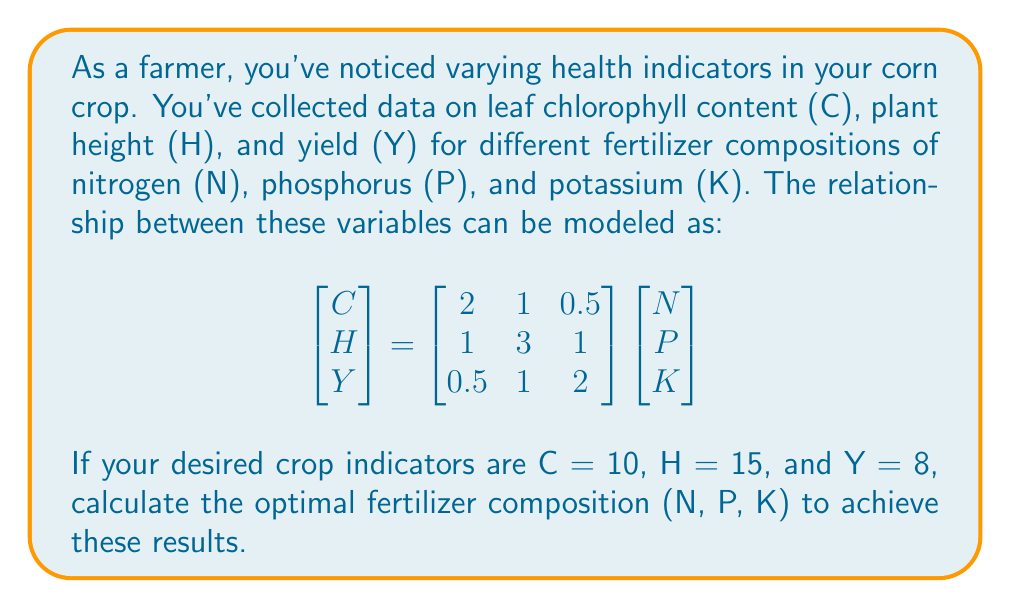Can you solve this math problem? To solve this inverse problem, we need to find the values of N, P, and K that satisfy the given equation with the desired crop indicators. Let's approach this step-by-step:

1) We have the equation:
   $$\begin{bmatrix} 10 \\ 15 \\ 8 \end{bmatrix} = \begin{bmatrix} 2 & 1 & 0.5 \\ 1 & 3 & 1 \\ 0.5 & 1 & 2 \end{bmatrix} \begin{bmatrix} N \\ P \\ K \end{bmatrix}$$

2) To solve for N, P, and K, we need to multiply both sides by the inverse of the 3x3 matrix:
   $$\begin{bmatrix} N \\ P \\ K \end{bmatrix} = \begin{bmatrix} 2 & 1 & 0.5 \\ 1 & 3 & 1 \\ 0.5 & 1 & 2 \end{bmatrix}^{-1} \begin{bmatrix} 10 \\ 15 \\ 8 \end{bmatrix}$$

3) Calculate the inverse of the 3x3 matrix:
   $$\begin{bmatrix} 2 & 1 & 0.5 \\ 1 & 3 & 1 \\ 0.5 & 1 & 2 \end{bmatrix}^{-1} = \frac{1}{11} \begin{bmatrix} 23 & -7 & -2 \\ -8 & 5 & 1 \\ 1 & -1 & 5 \end{bmatrix}$$

4) Now, multiply the inverse matrix by the desired crop indicators:
   $$\begin{bmatrix} N \\ P \\ K \end{bmatrix} = \frac{1}{11} \begin{bmatrix} 23 & -7 & -2 \\ -8 & 5 & 1 \\ 1 & -1 & 5 \end{bmatrix} \begin{bmatrix} 10 \\ 15 \\ 8 \end{bmatrix}$$

5) Perform the matrix multiplication:
   $$\begin{bmatrix} N \\ P \\ K \end{bmatrix} = \frac{1}{11} \begin{bmatrix} 23(10) + (-7)(15) + (-2)(8) \\ (-8)(10) + 5(15) + 1(8) \\ 1(10) + (-1)(15) + 5(8) \end{bmatrix} = \frac{1}{11} \begin{bmatrix} 125 \\ 33 \\ 55 \end{bmatrix}$$

6) Simplify:
   $$\begin{bmatrix} N \\ P \\ K \end{bmatrix} = \begin{bmatrix} 11.36 \\ 3 \\ 5 \end{bmatrix}$$

Therefore, the optimal fertilizer composition is approximately 11.36 units of nitrogen, 3 units of phosphorus, and 5 units of potassium.
Answer: N ≈ 11.36, P = 3, K = 5 